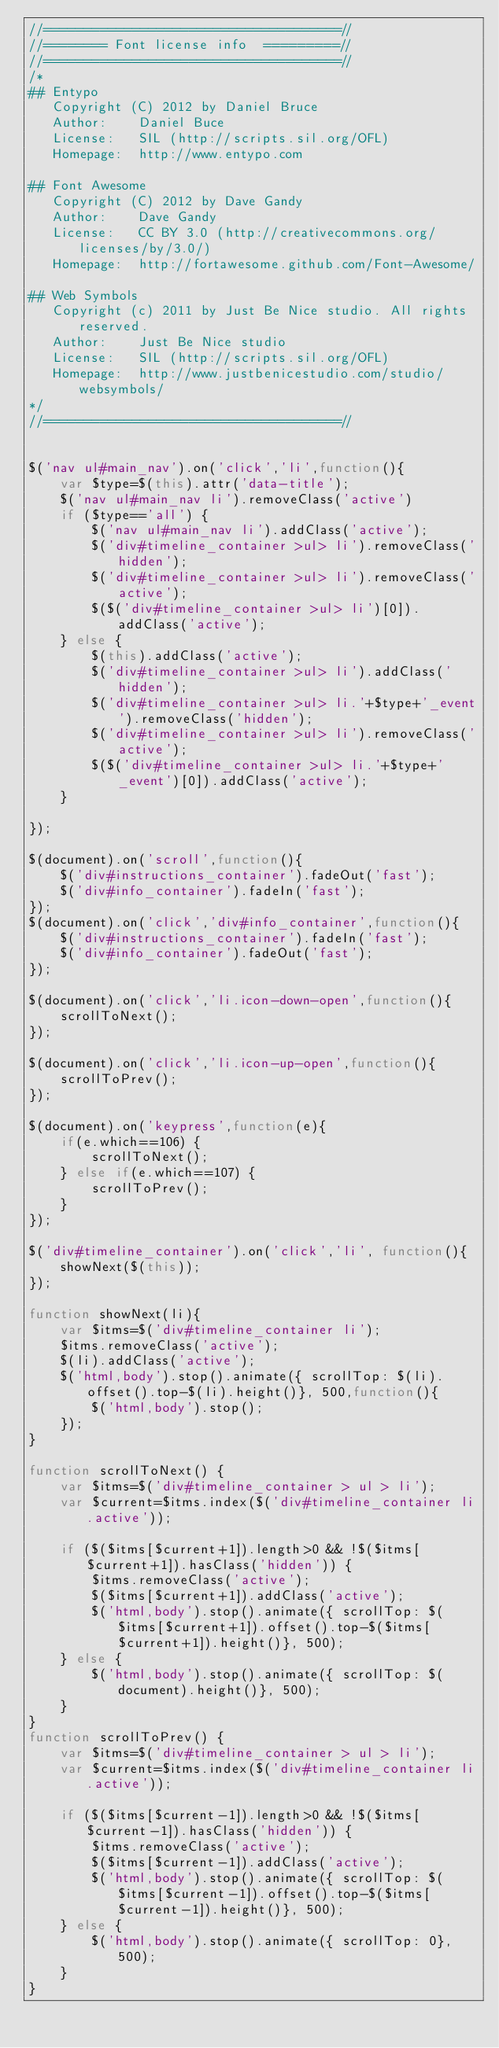Convert code to text. <code><loc_0><loc_0><loc_500><loc_500><_JavaScript_>//=====================================//
//======== Font license info  =========//
//=====================================//
/*    
## Entypo
   Copyright (C) 2012 by Daniel Bruce
   Author:    Daniel Buce
   License:   SIL (http://scripts.sil.org/OFL)
   Homepage:  http://www.entypo.com

## Font Awesome
   Copyright (C) 2012 by Dave Gandy
   Author:    Dave Gandy
   License:   CC BY 3.0 (http://creativecommons.org/licenses/by/3.0/)
   Homepage:  http://fortawesome.github.com/Font-Awesome/

## Web Symbols
   Copyright (c) 2011 by Just Be Nice studio. All rights reserved.
   Author:    Just Be Nice studio
   License:   SIL (http://scripts.sil.org/OFL)
   Homepage:  http://www.justbenicestudio.com/studio/websymbols/
*/
//=====================================//


$('nav ul#main_nav').on('click','li',function(){
	var $type=$(this).attr('data-title');
	$('nav ul#main_nav li').removeClass('active')
	if ($type=='all') {
		$('nav ul#main_nav li').addClass('active');
		$('div#timeline_container >ul> li').removeClass('hidden');
		$('div#timeline_container >ul> li').removeClass('active');
		$($('div#timeline_container >ul> li')[0]).addClass('active');
	} else {
		$(this).addClass('active');
		$('div#timeline_container >ul> li').addClass('hidden');	
		$('div#timeline_container >ul> li.'+$type+'_event').removeClass('hidden');
		$('div#timeline_container >ul> li').removeClass('active');
		$($('div#timeline_container >ul> li.'+$type+'_event')[0]).addClass('active');
	}
			
});

$(document).on('scroll',function(){
	$('div#instructions_container').fadeOut('fast');
	$('div#info_container').fadeIn('fast');
});
$(document).on('click','div#info_container',function(){
	$('div#instructions_container').fadeIn('fast');
	$('div#info_container').fadeOut('fast');
});

$(document).on('click','li.icon-down-open',function(){
	scrollToNext();
});

$(document).on('click','li.icon-up-open',function(){
	scrollToPrev();
});

$(document).on('keypress',function(e){
	if(e.which==106) {
		scrollToNext();
	} else if(e.which==107) {
		scrollToPrev();
	}
});

$('div#timeline_container').on('click','li', function(){
	showNext($(this));
});

function showNext(li){
	var $itms=$('div#timeline_container li');
	$itms.removeClass('active');
	$(li).addClass('active');
	$('html,body').stop().animate({ scrollTop: $(li).offset().top-$(li).height()}, 500,function(){
		$('html,body').stop();
	});
}

function scrollToNext() {
	var $itms=$('div#timeline_container > ul > li');
	var $current=$itms.index($('div#timeline_container li.active'));
	
	if ($($itms[$current+1]).length>0 && !$($itms[$current+1]).hasClass('hidden')) {
		$itms.removeClass('active');
		$($itms[$current+1]).addClass('active');
		$('html,body').stop().animate({ scrollTop: $($itms[$current+1]).offset().top-$($itms[$current+1]).height()}, 500);
	} else {
		$('html,body').stop().animate({ scrollTop: $(document).height()}, 500);
	}
}
function scrollToPrev() {
	var $itms=$('div#timeline_container > ul > li');
	var $current=$itms.index($('div#timeline_container li.active'));
	
	if ($($itms[$current-1]).length>0 && !$($itms[$current-1]).hasClass('hidden')) {
		$itms.removeClass('active');
		$($itms[$current-1]).addClass('active');
		$('html,body').stop().animate({ scrollTop: $($itms[$current-1]).offset().top-$($itms[$current-1]).height()}, 500);
	} else {
		$('html,body').stop().animate({ scrollTop: 0}, 500);
	}
}
</code> 